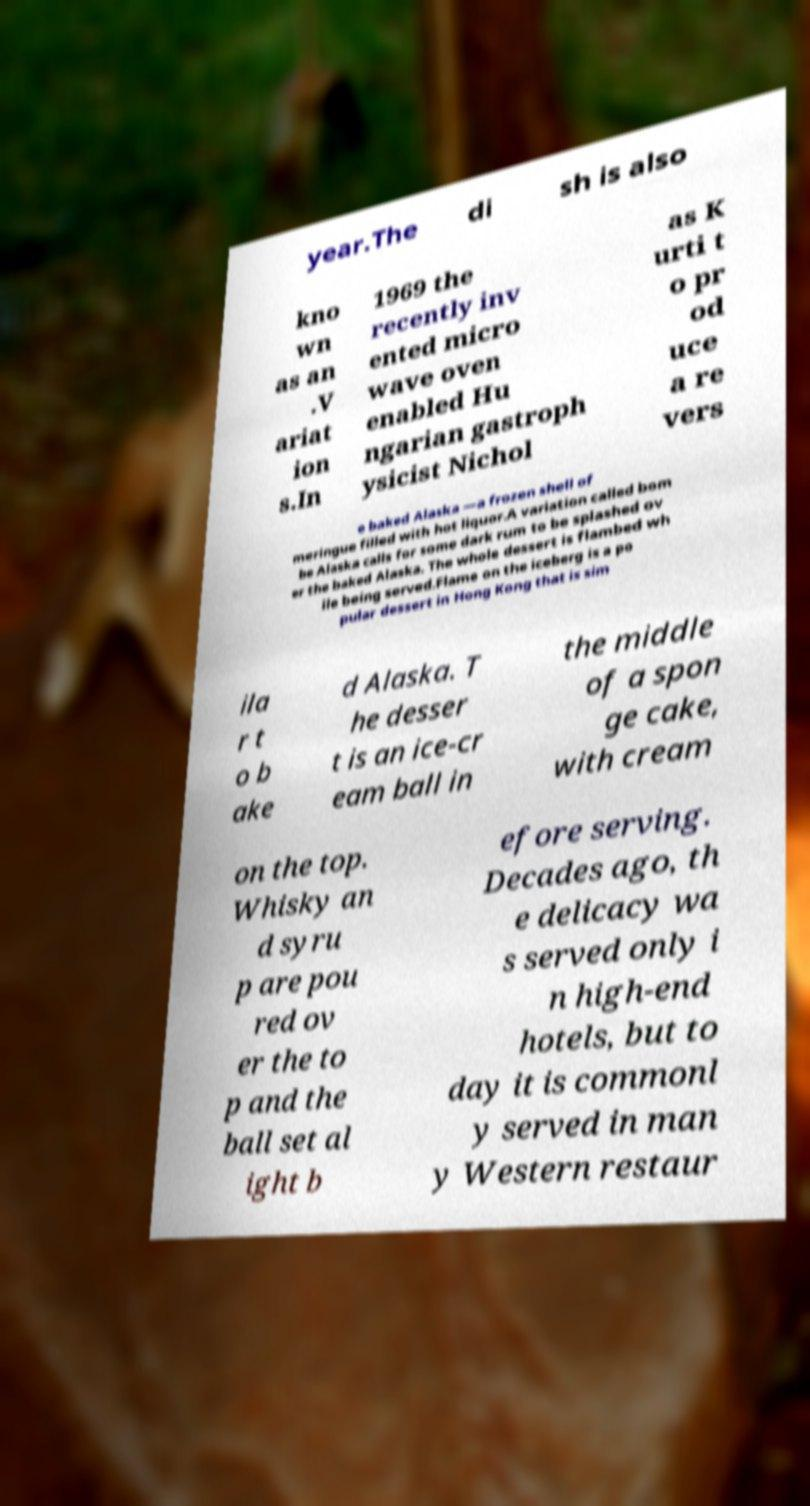What messages or text are displayed in this image? I need them in a readable, typed format. year.The di sh is also kno wn as an .V ariat ion s.In 1969 the recently inv ented micro wave oven enabled Hu ngarian gastroph ysicist Nichol as K urti t o pr od uce a re vers e baked Alaska —a frozen shell of meringue filled with hot liquor.A variation called bom be Alaska calls for some dark rum to be splashed ov er the baked Alaska. The whole dessert is flambed wh ile being served.Flame on the iceberg is a po pular dessert in Hong Kong that is sim ila r t o b ake d Alaska. T he desser t is an ice-cr eam ball in the middle of a spon ge cake, with cream on the top. Whisky an d syru p are pou red ov er the to p and the ball set al ight b efore serving. Decades ago, th e delicacy wa s served only i n high-end hotels, but to day it is commonl y served in man y Western restaur 